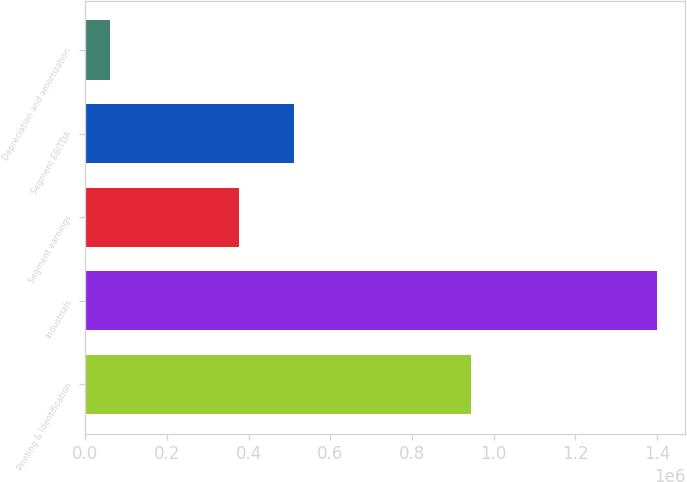<chart> <loc_0><loc_0><loc_500><loc_500><bar_chart><fcel>Printing & Identification<fcel>Industrials<fcel>Segment earnings<fcel>Segment EBITDA<fcel>Depreciation and amortization<nl><fcel>943670<fcel>1.39924e+06<fcel>376961<fcel>510894<fcel>59914<nl></chart> 